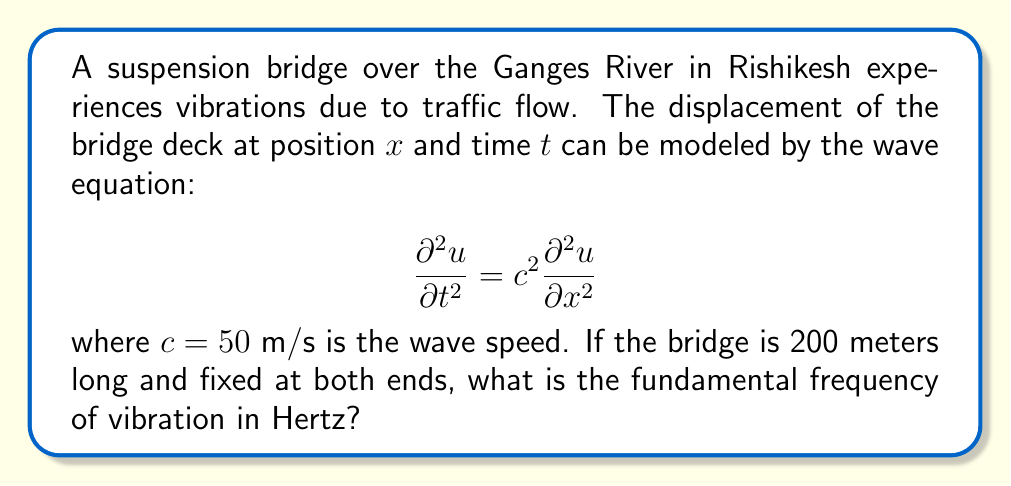Help me with this question. To solve this problem, we need to follow these steps:

1) The general solution for the wave equation with fixed ends (Dirichlet boundary conditions) is:

   $$u(x,t) = \sum_{n=1}^{\infty} A_n \sin(\frac{n\pi x}{L}) \cos(\frac{n\pi c t}{L})$$

   where $L$ is the length of the bridge.

2) The fundamental frequency corresponds to $n=1$ in this solution.

3) The angular frequency $\omega$ for the fundamental mode is:

   $$\omega = \frac{\pi c}{L}$$

4) We can convert angular frequency to frequency in Hertz using the relation:

   $$f = \frac{\omega}{2\pi}$$

5) Substituting the given values:
   $c = 50$ m/s
   $L = 200$ m

   $$f = \frac{1}{2L} c = \frac{1}{2(200)} (50) = 0.125$$ Hz

Therefore, the fundamental frequency of vibration is 0.125 Hz.
Answer: 0.125 Hz 